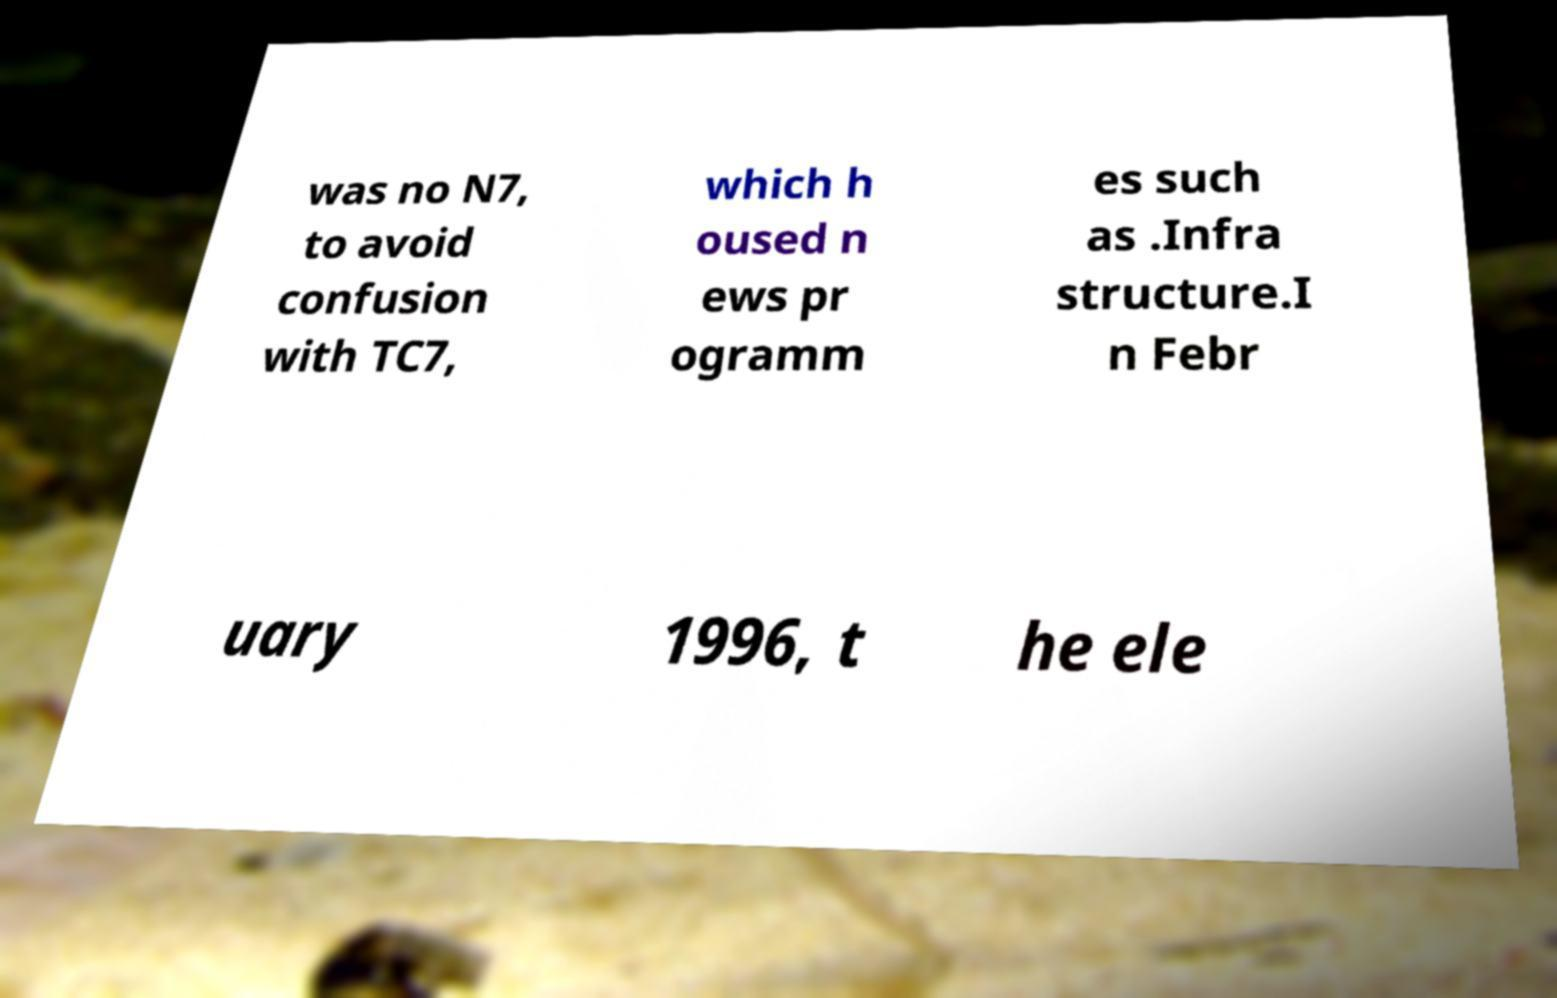Please read and relay the text visible in this image. What does it say? was no N7, to avoid confusion with TC7, which h oused n ews pr ogramm es such as .Infra structure.I n Febr uary 1996, t he ele 